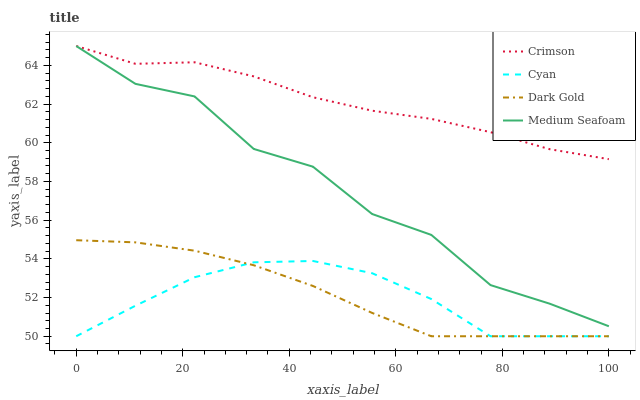Does Cyan have the minimum area under the curve?
Answer yes or no. Yes. Does Crimson have the maximum area under the curve?
Answer yes or no. Yes. Does Medium Seafoam have the minimum area under the curve?
Answer yes or no. No. Does Medium Seafoam have the maximum area under the curve?
Answer yes or no. No. Is Dark Gold the smoothest?
Answer yes or no. Yes. Is Medium Seafoam the roughest?
Answer yes or no. Yes. Is Cyan the smoothest?
Answer yes or no. No. Is Cyan the roughest?
Answer yes or no. No. Does Cyan have the lowest value?
Answer yes or no. Yes. Does Medium Seafoam have the lowest value?
Answer yes or no. No. Does Medium Seafoam have the highest value?
Answer yes or no. Yes. Does Cyan have the highest value?
Answer yes or no. No. Is Dark Gold less than Medium Seafoam?
Answer yes or no. Yes. Is Medium Seafoam greater than Cyan?
Answer yes or no. Yes. Does Medium Seafoam intersect Crimson?
Answer yes or no. Yes. Is Medium Seafoam less than Crimson?
Answer yes or no. No. Is Medium Seafoam greater than Crimson?
Answer yes or no. No. Does Dark Gold intersect Medium Seafoam?
Answer yes or no. No. 